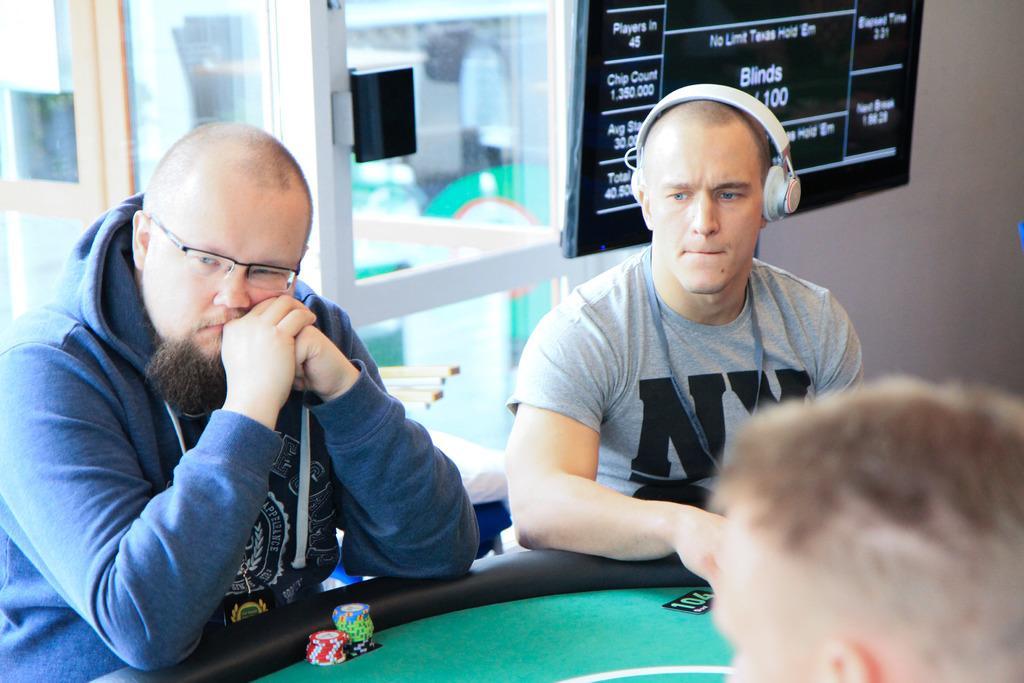Can you describe this image briefly? In this image I can see three men and between them I can see a poker table. On the bottom side I can see number of poker coins on the table. On the right side of the image I can see a white colour headphone on his head and on the left side I can see one of them is wearing specs. In the background I can see a black colour screen and on it I can see something is written. 